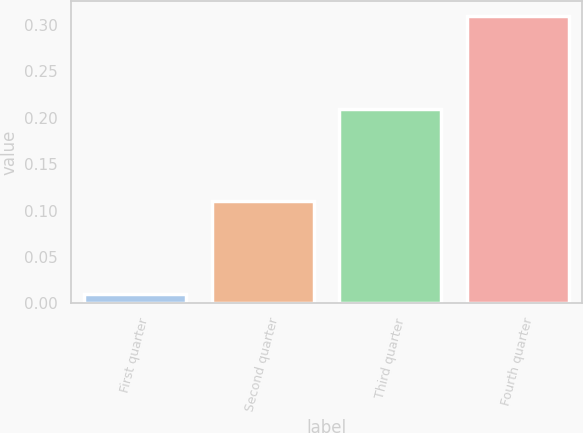<chart> <loc_0><loc_0><loc_500><loc_500><bar_chart><fcel>First quarter<fcel>Second quarter<fcel>Third quarter<fcel>Fourth quarter<nl><fcel>0.01<fcel>0.11<fcel>0.21<fcel>0.31<nl></chart> 